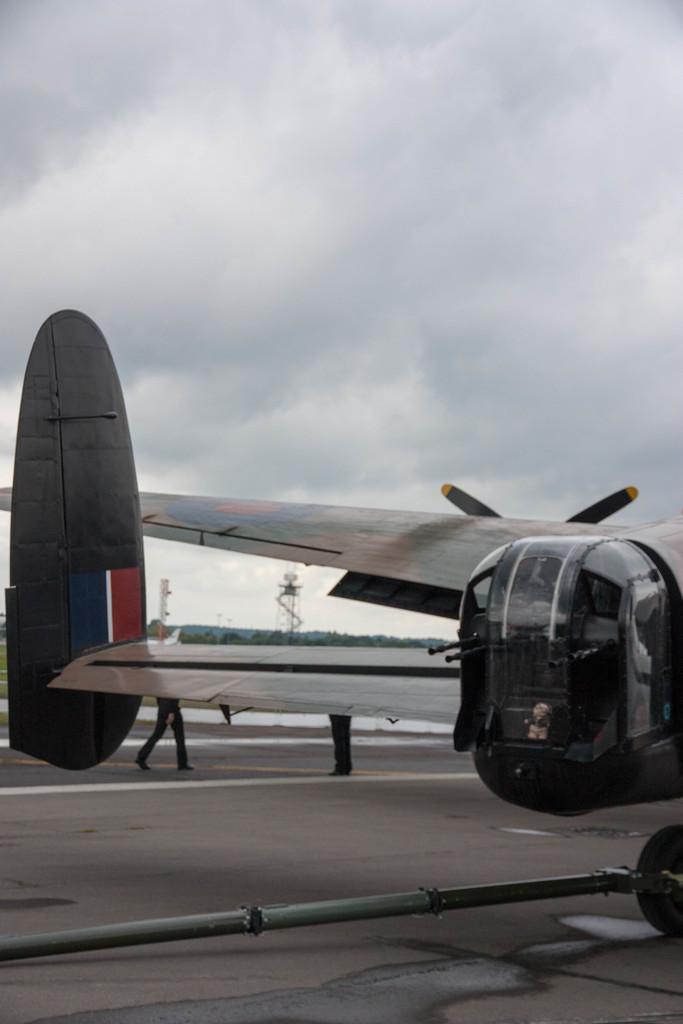Describe this image in one or two sentences. In this picture we can see a plane, two people legs on the ground and in the background we can see trees, towers and the sky. 